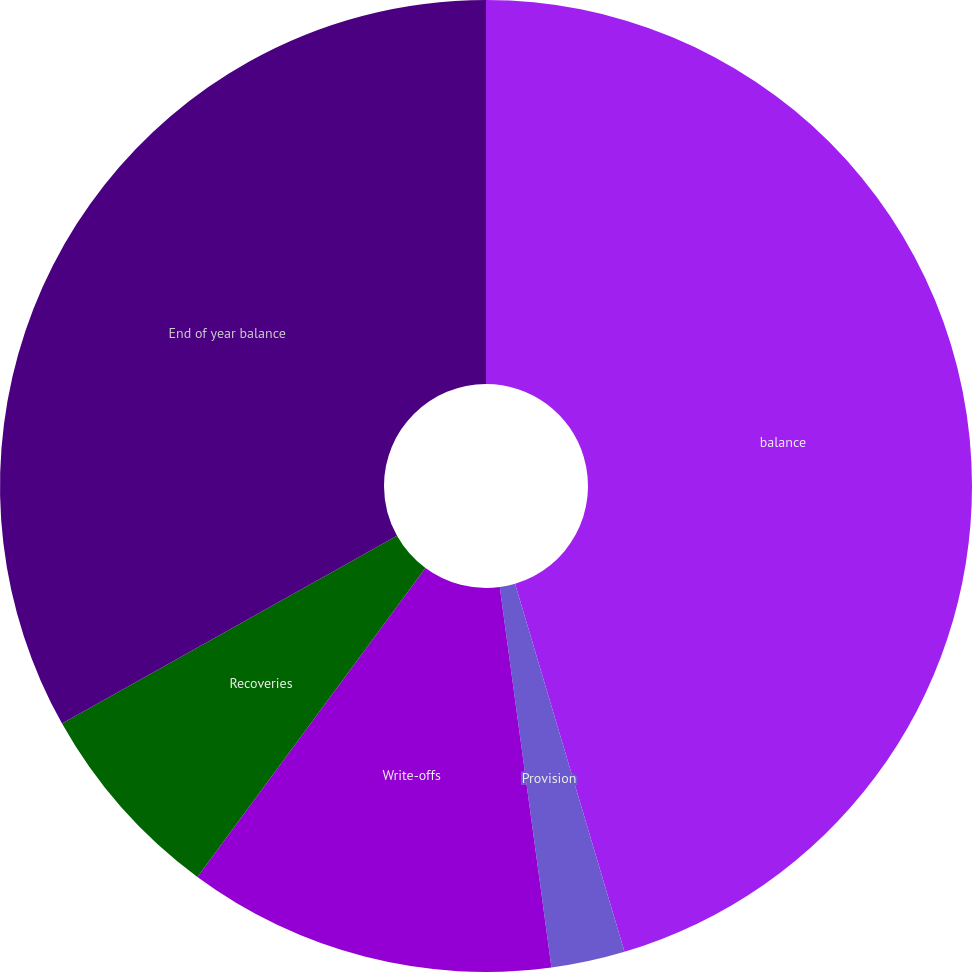Convert chart. <chart><loc_0><loc_0><loc_500><loc_500><pie_chart><fcel>balance<fcel>Provision<fcel>Write-offs<fcel>Recoveries<fcel>End of year balance<nl><fcel>45.4%<fcel>2.45%<fcel>12.27%<fcel>6.75%<fcel>33.13%<nl></chart> 